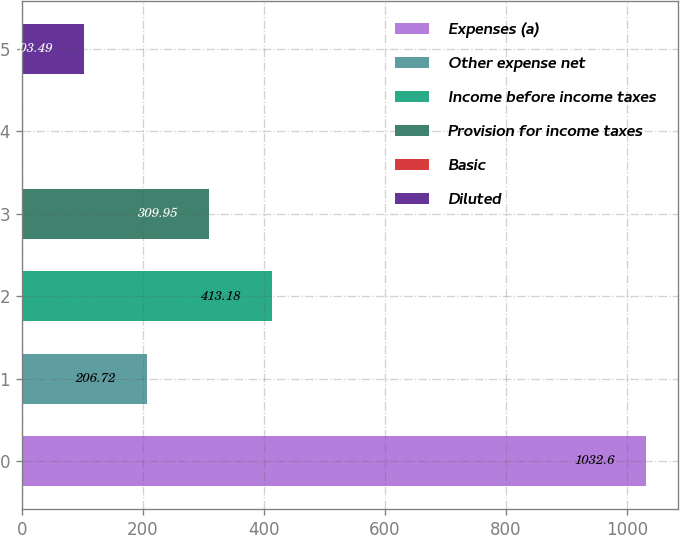Convert chart to OTSL. <chart><loc_0><loc_0><loc_500><loc_500><bar_chart><fcel>Expenses (a)<fcel>Other expense net<fcel>Income before income taxes<fcel>Provision for income taxes<fcel>Basic<fcel>Diluted<nl><fcel>1032.6<fcel>206.72<fcel>413.18<fcel>309.95<fcel>0.26<fcel>103.49<nl></chart> 